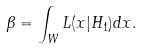<formula> <loc_0><loc_0><loc_500><loc_500>\beta = \int _ { W } L ( x | H _ { 1 } ) d x .</formula> 